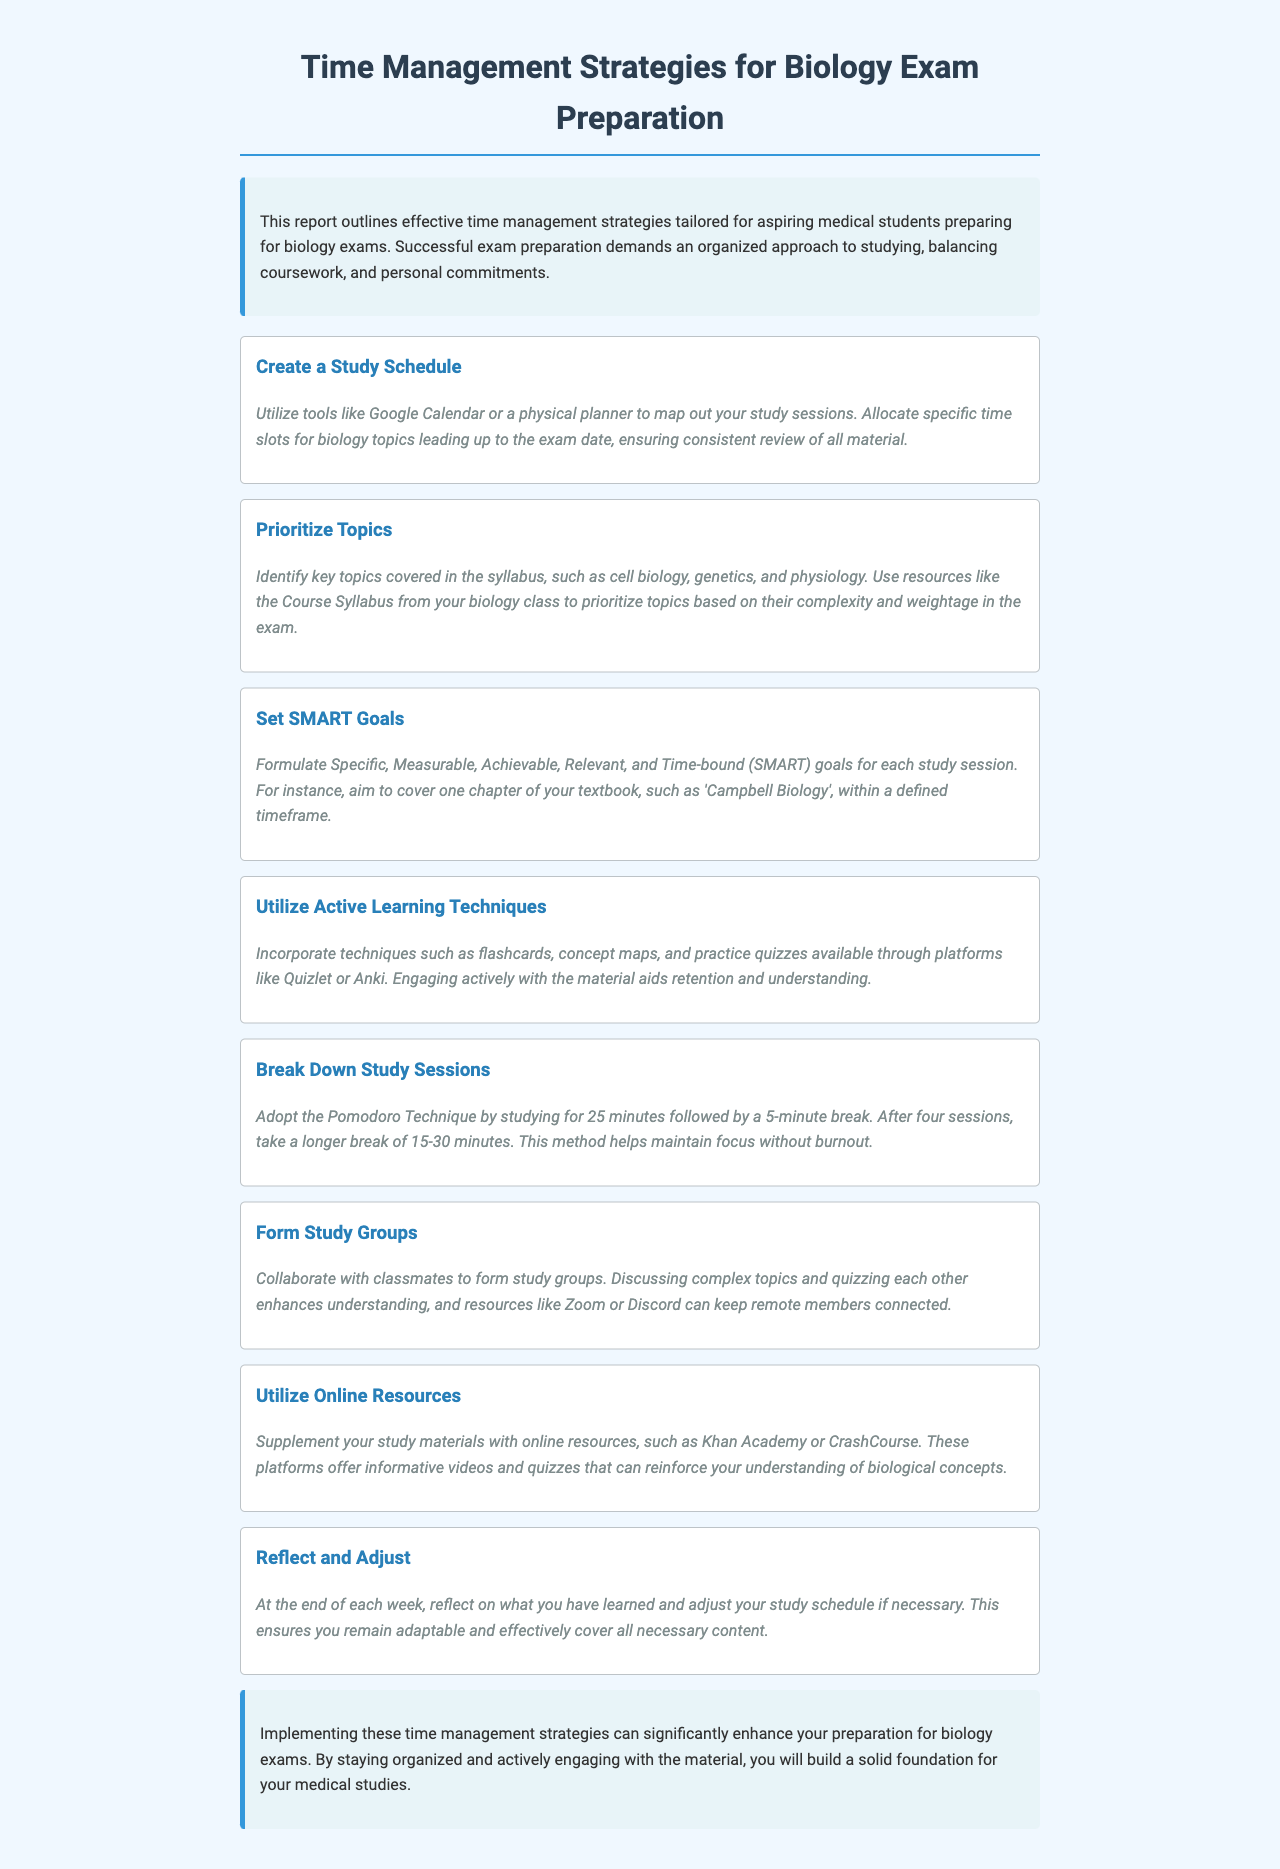What is the title of the report? The title of the report is indicated at the top of the document.
Answer: Time Management Strategies for Biology Exam Preparation What is one tool recommended for creating a study schedule? The document suggests specific tools for mapping out study sessions.
Answer: Google Calendar What does SMART stand for in study goals? The document explains what SMART goals are in detail.
Answer: Specific, Measurable, Achievable, Relevant, Time-bound What technique is suggested for maintaining focus during study sessions? The report outlines a specific technique involving breaks to maintain focus.
Answer: Pomodoro Technique What online platform is mentioned for practice quizzes? The document lists platforms that can aid in active learning.
Answer: Quizlet What is recommended at the end of each week regarding the study schedule? The report advises on how to assess weekly progress on study content.
Answer: Reflect and Adjust How should study groups function according to the document? The report describes the purpose and method of forming study groups.
Answer: Discuss and quiz each other What is one benefit of using online resources for study? The report highlights the advantages of supplementing study materials.
Answer: Reinforce understanding What kind of approach does successful exam preparation demand? The document states an essential quality required for effective exam preparation.
Answer: Organized approach 